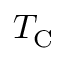<formula> <loc_0><loc_0><loc_500><loc_500>T _ { C }</formula> 